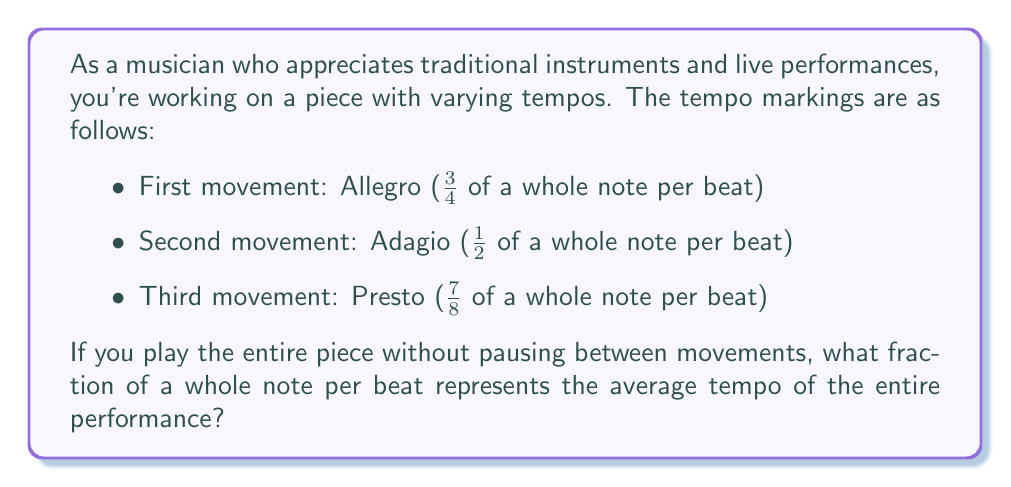Teach me how to tackle this problem. To find the average tempo, we need to:
1. Convert each tempo marking to a fraction of a whole note per beat
2. Add these fractions together
3. Divide the sum by the number of movements

Let's go through this step-by-step:

1. The fractions are already given:
   - First movement: $\frac{3}{4}$
   - Second movement: $\frac{1}{2}$
   - Third movement: $\frac{7}{8}$

2. Adding these fractions:
   $$\frac{3}{4} + \frac{1}{2} + \frac{7}{8}$$
   
   To add fractions with different denominators, we need a common denominator. The least common multiple of 4, 2, and 8 is 8. So, we'll convert each fraction to an equivalent fraction with denominator 8:

   $$\frac{3}{4} = \frac{6}{8}$$
   $$\frac{1}{2} = \frac{4}{8}$$
   $$\frac{7}{8} \text{ (already in eighths)}$$

   Now we can add:
   $$\frac{6}{8} + \frac{4}{8} + \frac{7}{8} = \frac{17}{8}$$

3. Dividing by the number of movements (3):
   $$\frac{17}{8} \div 3 = \frac{17}{24}$$

Therefore, the average tempo for the entire piece is $\frac{17}{24}$ of a whole note per beat.
Answer: $\frac{17}{24}$ of a whole note per beat 